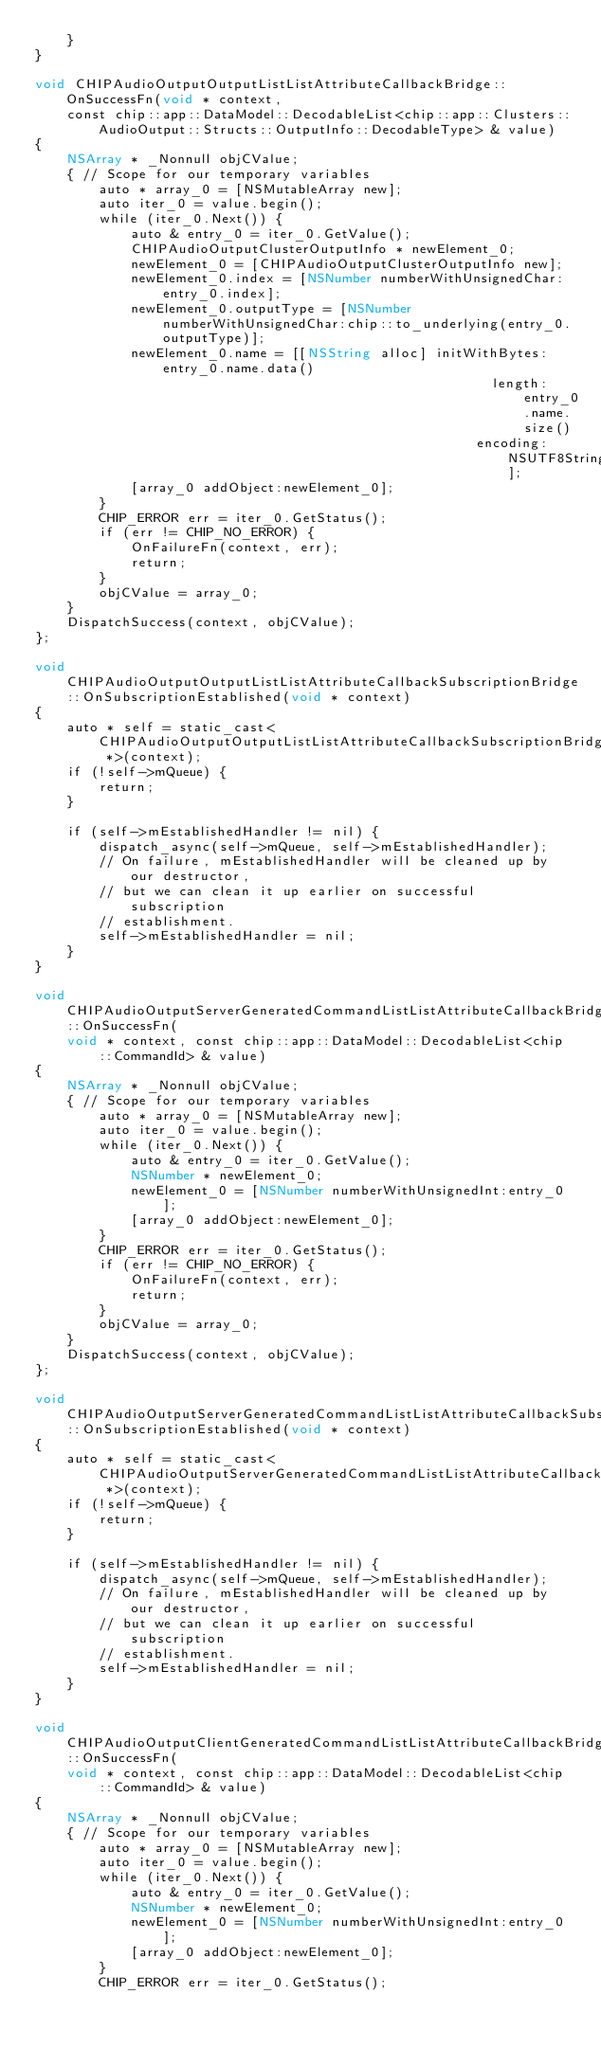<code> <loc_0><loc_0><loc_500><loc_500><_ObjectiveC_>    }
}

void CHIPAudioOutputOutputListListAttributeCallbackBridge::OnSuccessFn(void * context,
    const chip::app::DataModel::DecodableList<chip::app::Clusters::AudioOutput::Structs::OutputInfo::DecodableType> & value)
{
    NSArray * _Nonnull objCValue;
    { // Scope for our temporary variables
        auto * array_0 = [NSMutableArray new];
        auto iter_0 = value.begin();
        while (iter_0.Next()) {
            auto & entry_0 = iter_0.GetValue();
            CHIPAudioOutputClusterOutputInfo * newElement_0;
            newElement_0 = [CHIPAudioOutputClusterOutputInfo new];
            newElement_0.index = [NSNumber numberWithUnsignedChar:entry_0.index];
            newElement_0.outputType = [NSNumber numberWithUnsignedChar:chip::to_underlying(entry_0.outputType)];
            newElement_0.name = [[NSString alloc] initWithBytes:entry_0.name.data()
                                                         length:entry_0.name.size()
                                                       encoding:NSUTF8StringEncoding];
            [array_0 addObject:newElement_0];
        }
        CHIP_ERROR err = iter_0.GetStatus();
        if (err != CHIP_NO_ERROR) {
            OnFailureFn(context, err);
            return;
        }
        objCValue = array_0;
    }
    DispatchSuccess(context, objCValue);
};

void CHIPAudioOutputOutputListListAttributeCallbackSubscriptionBridge::OnSubscriptionEstablished(void * context)
{
    auto * self = static_cast<CHIPAudioOutputOutputListListAttributeCallbackSubscriptionBridge *>(context);
    if (!self->mQueue) {
        return;
    }

    if (self->mEstablishedHandler != nil) {
        dispatch_async(self->mQueue, self->mEstablishedHandler);
        // On failure, mEstablishedHandler will be cleaned up by our destructor,
        // but we can clean it up earlier on successful subscription
        // establishment.
        self->mEstablishedHandler = nil;
    }
}

void CHIPAudioOutputServerGeneratedCommandListListAttributeCallbackBridge::OnSuccessFn(
    void * context, const chip::app::DataModel::DecodableList<chip::CommandId> & value)
{
    NSArray * _Nonnull objCValue;
    { // Scope for our temporary variables
        auto * array_0 = [NSMutableArray new];
        auto iter_0 = value.begin();
        while (iter_0.Next()) {
            auto & entry_0 = iter_0.GetValue();
            NSNumber * newElement_0;
            newElement_0 = [NSNumber numberWithUnsignedInt:entry_0];
            [array_0 addObject:newElement_0];
        }
        CHIP_ERROR err = iter_0.GetStatus();
        if (err != CHIP_NO_ERROR) {
            OnFailureFn(context, err);
            return;
        }
        objCValue = array_0;
    }
    DispatchSuccess(context, objCValue);
};

void CHIPAudioOutputServerGeneratedCommandListListAttributeCallbackSubscriptionBridge::OnSubscriptionEstablished(void * context)
{
    auto * self = static_cast<CHIPAudioOutputServerGeneratedCommandListListAttributeCallbackSubscriptionBridge *>(context);
    if (!self->mQueue) {
        return;
    }

    if (self->mEstablishedHandler != nil) {
        dispatch_async(self->mQueue, self->mEstablishedHandler);
        // On failure, mEstablishedHandler will be cleaned up by our destructor,
        // but we can clean it up earlier on successful subscription
        // establishment.
        self->mEstablishedHandler = nil;
    }
}

void CHIPAudioOutputClientGeneratedCommandListListAttributeCallbackBridge::OnSuccessFn(
    void * context, const chip::app::DataModel::DecodableList<chip::CommandId> & value)
{
    NSArray * _Nonnull objCValue;
    { // Scope for our temporary variables
        auto * array_0 = [NSMutableArray new];
        auto iter_0 = value.begin();
        while (iter_0.Next()) {
            auto & entry_0 = iter_0.GetValue();
            NSNumber * newElement_0;
            newElement_0 = [NSNumber numberWithUnsignedInt:entry_0];
            [array_0 addObject:newElement_0];
        }
        CHIP_ERROR err = iter_0.GetStatus();</code> 